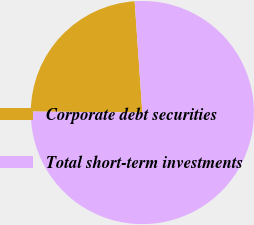Convert chart. <chart><loc_0><loc_0><loc_500><loc_500><pie_chart><fcel>Corporate debt securities<fcel>Total short-term investments<nl><fcel>23.75%<fcel>76.25%<nl></chart> 